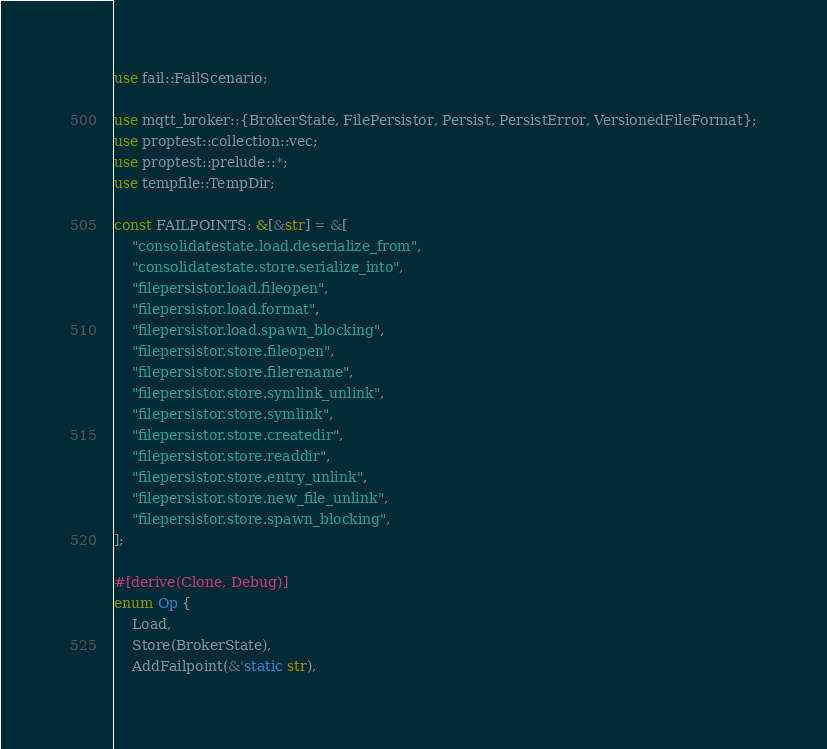Convert code to text. <code><loc_0><loc_0><loc_500><loc_500><_Rust_>use fail::FailScenario;

use mqtt_broker::{BrokerState, FilePersistor, Persist, PersistError, VersionedFileFormat};
use proptest::collection::vec;
use proptest::prelude::*;
use tempfile::TempDir;

const FAILPOINTS: &[&str] = &[
    "consolidatestate.load.deserialize_from",
    "consolidatestate.store.serialize_into",
    "filepersistor.load.fileopen",
    "filepersistor.load.format",
    "filepersistor.load.spawn_blocking",
    "filepersistor.store.fileopen",
    "filepersistor.store.filerename",
    "filepersistor.store.symlink_unlink",
    "filepersistor.store.symlink",
    "filepersistor.store.createdir",
    "filepersistor.store.readdir",
    "filepersistor.store.entry_unlink",
    "filepersistor.store.new_file_unlink",
    "filepersistor.store.spawn_blocking",
];

#[derive(Clone, Debug)]
enum Op {
    Load,
    Store(BrokerState),
    AddFailpoint(&'static str),</code> 